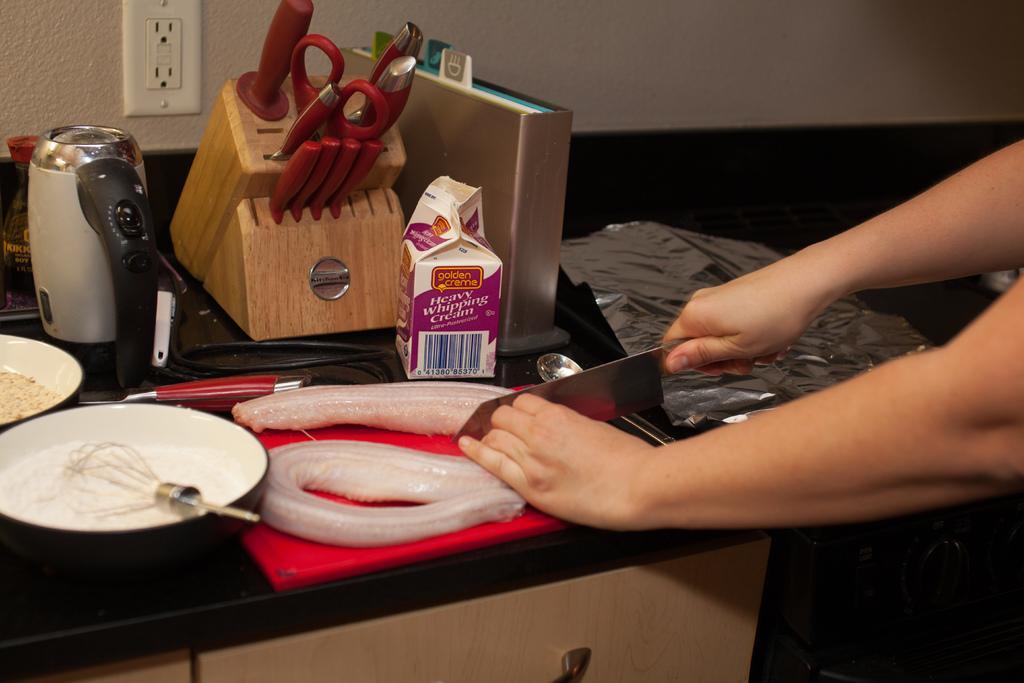In one or two sentences, can you explain what this image depicts? In this image we can see some person cutting fish with the help of the knife. Image also consists of a stirrer, containers, scissor and also cream pack placed on the counter. 